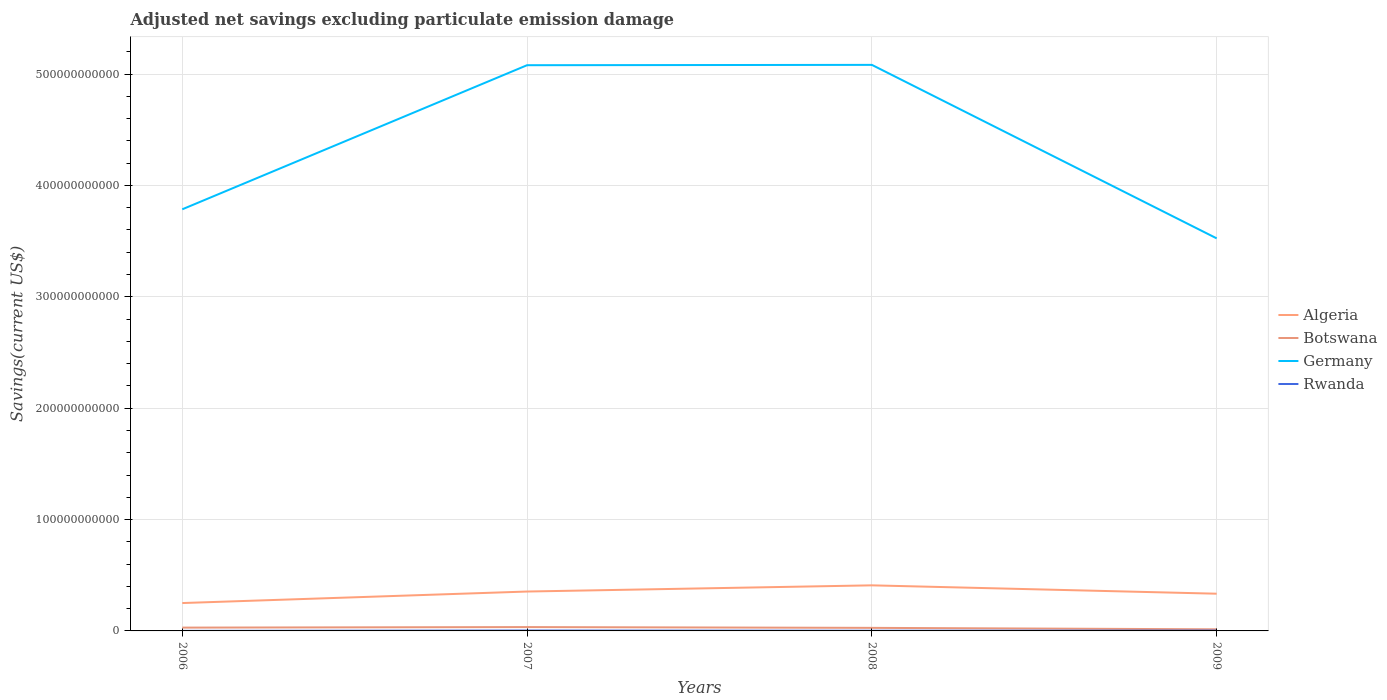How many different coloured lines are there?
Provide a short and direct response. 4. Does the line corresponding to Botswana intersect with the line corresponding to Algeria?
Provide a short and direct response. No. Is the number of lines equal to the number of legend labels?
Ensure brevity in your answer.  Yes. Across all years, what is the maximum adjusted net savings in Botswana?
Keep it short and to the point. 1.44e+09. What is the total adjusted net savings in Rwanda in the graph?
Make the answer very short. -1.05e+08. What is the difference between the highest and the second highest adjusted net savings in Germany?
Provide a short and direct response. 1.56e+11. How many lines are there?
Provide a succinct answer. 4. How many years are there in the graph?
Provide a short and direct response. 4. What is the difference between two consecutive major ticks on the Y-axis?
Offer a very short reply. 1.00e+11. Where does the legend appear in the graph?
Provide a short and direct response. Center right. How many legend labels are there?
Offer a very short reply. 4. What is the title of the graph?
Your answer should be very brief. Adjusted net savings excluding particulate emission damage. What is the label or title of the X-axis?
Your response must be concise. Years. What is the label or title of the Y-axis?
Your answer should be very brief. Savings(current US$). What is the Savings(current US$) in Algeria in 2006?
Make the answer very short. 2.50e+1. What is the Savings(current US$) of Botswana in 2006?
Your response must be concise. 2.97e+09. What is the Savings(current US$) of Germany in 2006?
Offer a terse response. 3.79e+11. What is the Savings(current US$) in Rwanda in 2006?
Give a very brief answer. 5.25e+07. What is the Savings(current US$) of Algeria in 2007?
Your response must be concise. 3.54e+1. What is the Savings(current US$) of Botswana in 2007?
Give a very brief answer. 3.46e+09. What is the Savings(current US$) in Germany in 2007?
Your response must be concise. 5.08e+11. What is the Savings(current US$) of Rwanda in 2007?
Your response must be concise. 3.66e+08. What is the Savings(current US$) of Algeria in 2008?
Your response must be concise. 4.09e+1. What is the Savings(current US$) in Botswana in 2008?
Give a very brief answer. 2.75e+09. What is the Savings(current US$) of Germany in 2008?
Keep it short and to the point. 5.08e+11. What is the Savings(current US$) in Rwanda in 2008?
Your answer should be very brief. 1.84e+08. What is the Savings(current US$) of Algeria in 2009?
Provide a succinct answer. 3.34e+1. What is the Savings(current US$) in Botswana in 2009?
Provide a succinct answer. 1.44e+09. What is the Savings(current US$) of Germany in 2009?
Offer a very short reply. 3.52e+11. What is the Savings(current US$) of Rwanda in 2009?
Offer a terse response. 2.89e+08. Across all years, what is the maximum Savings(current US$) of Algeria?
Your response must be concise. 4.09e+1. Across all years, what is the maximum Savings(current US$) of Botswana?
Make the answer very short. 3.46e+09. Across all years, what is the maximum Savings(current US$) of Germany?
Offer a terse response. 5.08e+11. Across all years, what is the maximum Savings(current US$) of Rwanda?
Offer a terse response. 3.66e+08. Across all years, what is the minimum Savings(current US$) of Algeria?
Give a very brief answer. 2.50e+1. Across all years, what is the minimum Savings(current US$) of Botswana?
Provide a short and direct response. 1.44e+09. Across all years, what is the minimum Savings(current US$) of Germany?
Your answer should be compact. 3.52e+11. Across all years, what is the minimum Savings(current US$) in Rwanda?
Offer a very short reply. 5.25e+07. What is the total Savings(current US$) in Algeria in the graph?
Ensure brevity in your answer.  1.35e+11. What is the total Savings(current US$) in Botswana in the graph?
Ensure brevity in your answer.  1.06e+1. What is the total Savings(current US$) in Germany in the graph?
Offer a very short reply. 1.75e+12. What is the total Savings(current US$) of Rwanda in the graph?
Ensure brevity in your answer.  8.91e+08. What is the difference between the Savings(current US$) in Algeria in 2006 and that in 2007?
Offer a terse response. -1.03e+1. What is the difference between the Savings(current US$) in Botswana in 2006 and that in 2007?
Your answer should be very brief. -4.86e+08. What is the difference between the Savings(current US$) in Germany in 2006 and that in 2007?
Make the answer very short. -1.29e+11. What is the difference between the Savings(current US$) of Rwanda in 2006 and that in 2007?
Offer a very short reply. -3.13e+08. What is the difference between the Savings(current US$) of Algeria in 2006 and that in 2008?
Make the answer very short. -1.59e+1. What is the difference between the Savings(current US$) in Botswana in 2006 and that in 2008?
Make the answer very short. 2.21e+08. What is the difference between the Savings(current US$) of Germany in 2006 and that in 2008?
Keep it short and to the point. -1.30e+11. What is the difference between the Savings(current US$) in Rwanda in 2006 and that in 2008?
Offer a terse response. -1.32e+08. What is the difference between the Savings(current US$) in Algeria in 2006 and that in 2009?
Your answer should be very brief. -8.39e+09. What is the difference between the Savings(current US$) of Botswana in 2006 and that in 2009?
Offer a very short reply. 1.53e+09. What is the difference between the Savings(current US$) of Germany in 2006 and that in 2009?
Give a very brief answer. 2.61e+1. What is the difference between the Savings(current US$) of Rwanda in 2006 and that in 2009?
Keep it short and to the point. -2.36e+08. What is the difference between the Savings(current US$) of Algeria in 2007 and that in 2008?
Ensure brevity in your answer.  -5.56e+09. What is the difference between the Savings(current US$) in Botswana in 2007 and that in 2008?
Give a very brief answer. 7.07e+08. What is the difference between the Savings(current US$) in Germany in 2007 and that in 2008?
Make the answer very short. -2.97e+08. What is the difference between the Savings(current US$) of Rwanda in 2007 and that in 2008?
Offer a terse response. 1.82e+08. What is the difference between the Savings(current US$) in Algeria in 2007 and that in 2009?
Keep it short and to the point. 1.95e+09. What is the difference between the Savings(current US$) of Botswana in 2007 and that in 2009?
Your answer should be very brief. 2.02e+09. What is the difference between the Savings(current US$) in Germany in 2007 and that in 2009?
Provide a succinct answer. 1.55e+11. What is the difference between the Savings(current US$) in Rwanda in 2007 and that in 2009?
Ensure brevity in your answer.  7.70e+07. What is the difference between the Savings(current US$) in Algeria in 2008 and that in 2009?
Make the answer very short. 7.50e+09. What is the difference between the Savings(current US$) in Botswana in 2008 and that in 2009?
Provide a succinct answer. 1.31e+09. What is the difference between the Savings(current US$) in Germany in 2008 and that in 2009?
Give a very brief answer. 1.56e+11. What is the difference between the Savings(current US$) in Rwanda in 2008 and that in 2009?
Make the answer very short. -1.05e+08. What is the difference between the Savings(current US$) of Algeria in 2006 and the Savings(current US$) of Botswana in 2007?
Offer a very short reply. 2.16e+1. What is the difference between the Savings(current US$) of Algeria in 2006 and the Savings(current US$) of Germany in 2007?
Offer a terse response. -4.83e+11. What is the difference between the Savings(current US$) in Algeria in 2006 and the Savings(current US$) in Rwanda in 2007?
Provide a succinct answer. 2.47e+1. What is the difference between the Savings(current US$) in Botswana in 2006 and the Savings(current US$) in Germany in 2007?
Your answer should be very brief. -5.05e+11. What is the difference between the Savings(current US$) of Botswana in 2006 and the Savings(current US$) of Rwanda in 2007?
Give a very brief answer. 2.60e+09. What is the difference between the Savings(current US$) of Germany in 2006 and the Savings(current US$) of Rwanda in 2007?
Provide a succinct answer. 3.78e+11. What is the difference between the Savings(current US$) in Algeria in 2006 and the Savings(current US$) in Botswana in 2008?
Keep it short and to the point. 2.23e+1. What is the difference between the Savings(current US$) in Algeria in 2006 and the Savings(current US$) in Germany in 2008?
Give a very brief answer. -4.83e+11. What is the difference between the Savings(current US$) of Algeria in 2006 and the Savings(current US$) of Rwanda in 2008?
Offer a terse response. 2.48e+1. What is the difference between the Savings(current US$) in Botswana in 2006 and the Savings(current US$) in Germany in 2008?
Offer a terse response. -5.05e+11. What is the difference between the Savings(current US$) of Botswana in 2006 and the Savings(current US$) of Rwanda in 2008?
Provide a succinct answer. 2.79e+09. What is the difference between the Savings(current US$) in Germany in 2006 and the Savings(current US$) in Rwanda in 2008?
Provide a succinct answer. 3.78e+11. What is the difference between the Savings(current US$) of Algeria in 2006 and the Savings(current US$) of Botswana in 2009?
Offer a very short reply. 2.36e+1. What is the difference between the Savings(current US$) in Algeria in 2006 and the Savings(current US$) in Germany in 2009?
Your answer should be very brief. -3.27e+11. What is the difference between the Savings(current US$) in Algeria in 2006 and the Savings(current US$) in Rwanda in 2009?
Your answer should be very brief. 2.47e+1. What is the difference between the Savings(current US$) in Botswana in 2006 and the Savings(current US$) in Germany in 2009?
Your answer should be very brief. -3.50e+11. What is the difference between the Savings(current US$) of Botswana in 2006 and the Savings(current US$) of Rwanda in 2009?
Offer a terse response. 2.68e+09. What is the difference between the Savings(current US$) in Germany in 2006 and the Savings(current US$) in Rwanda in 2009?
Make the answer very short. 3.78e+11. What is the difference between the Savings(current US$) of Algeria in 2007 and the Savings(current US$) of Botswana in 2008?
Your answer should be compact. 3.26e+1. What is the difference between the Savings(current US$) in Algeria in 2007 and the Savings(current US$) in Germany in 2008?
Offer a terse response. -4.73e+11. What is the difference between the Savings(current US$) in Algeria in 2007 and the Savings(current US$) in Rwanda in 2008?
Offer a terse response. 3.52e+1. What is the difference between the Savings(current US$) in Botswana in 2007 and the Savings(current US$) in Germany in 2008?
Offer a terse response. -5.05e+11. What is the difference between the Savings(current US$) in Botswana in 2007 and the Savings(current US$) in Rwanda in 2008?
Your answer should be very brief. 3.27e+09. What is the difference between the Savings(current US$) of Germany in 2007 and the Savings(current US$) of Rwanda in 2008?
Keep it short and to the point. 5.08e+11. What is the difference between the Savings(current US$) in Algeria in 2007 and the Savings(current US$) in Botswana in 2009?
Offer a very short reply. 3.39e+1. What is the difference between the Savings(current US$) of Algeria in 2007 and the Savings(current US$) of Germany in 2009?
Ensure brevity in your answer.  -3.17e+11. What is the difference between the Savings(current US$) in Algeria in 2007 and the Savings(current US$) in Rwanda in 2009?
Your response must be concise. 3.51e+1. What is the difference between the Savings(current US$) of Botswana in 2007 and the Savings(current US$) of Germany in 2009?
Offer a very short reply. -3.49e+11. What is the difference between the Savings(current US$) in Botswana in 2007 and the Savings(current US$) in Rwanda in 2009?
Give a very brief answer. 3.17e+09. What is the difference between the Savings(current US$) in Germany in 2007 and the Savings(current US$) in Rwanda in 2009?
Keep it short and to the point. 5.08e+11. What is the difference between the Savings(current US$) in Algeria in 2008 and the Savings(current US$) in Botswana in 2009?
Offer a terse response. 3.95e+1. What is the difference between the Savings(current US$) of Algeria in 2008 and the Savings(current US$) of Germany in 2009?
Your response must be concise. -3.12e+11. What is the difference between the Savings(current US$) of Algeria in 2008 and the Savings(current US$) of Rwanda in 2009?
Provide a short and direct response. 4.06e+1. What is the difference between the Savings(current US$) of Botswana in 2008 and the Savings(current US$) of Germany in 2009?
Keep it short and to the point. -3.50e+11. What is the difference between the Savings(current US$) of Botswana in 2008 and the Savings(current US$) of Rwanda in 2009?
Ensure brevity in your answer.  2.46e+09. What is the difference between the Savings(current US$) in Germany in 2008 and the Savings(current US$) in Rwanda in 2009?
Keep it short and to the point. 5.08e+11. What is the average Savings(current US$) in Algeria per year?
Make the answer very short. 3.37e+1. What is the average Savings(current US$) in Botswana per year?
Provide a succinct answer. 2.65e+09. What is the average Savings(current US$) in Germany per year?
Give a very brief answer. 4.37e+11. What is the average Savings(current US$) in Rwanda per year?
Provide a short and direct response. 2.23e+08. In the year 2006, what is the difference between the Savings(current US$) in Algeria and Savings(current US$) in Botswana?
Offer a terse response. 2.21e+1. In the year 2006, what is the difference between the Savings(current US$) in Algeria and Savings(current US$) in Germany?
Your answer should be compact. -3.54e+11. In the year 2006, what is the difference between the Savings(current US$) of Algeria and Savings(current US$) of Rwanda?
Provide a short and direct response. 2.50e+1. In the year 2006, what is the difference between the Savings(current US$) of Botswana and Savings(current US$) of Germany?
Offer a very short reply. -3.76e+11. In the year 2006, what is the difference between the Savings(current US$) of Botswana and Savings(current US$) of Rwanda?
Your answer should be very brief. 2.92e+09. In the year 2006, what is the difference between the Savings(current US$) in Germany and Savings(current US$) in Rwanda?
Provide a short and direct response. 3.79e+11. In the year 2007, what is the difference between the Savings(current US$) in Algeria and Savings(current US$) in Botswana?
Give a very brief answer. 3.19e+1. In the year 2007, what is the difference between the Savings(current US$) of Algeria and Savings(current US$) of Germany?
Provide a succinct answer. -4.73e+11. In the year 2007, what is the difference between the Savings(current US$) in Algeria and Savings(current US$) in Rwanda?
Ensure brevity in your answer.  3.50e+1. In the year 2007, what is the difference between the Savings(current US$) in Botswana and Savings(current US$) in Germany?
Provide a succinct answer. -5.05e+11. In the year 2007, what is the difference between the Savings(current US$) of Botswana and Savings(current US$) of Rwanda?
Your answer should be very brief. 3.09e+09. In the year 2007, what is the difference between the Savings(current US$) of Germany and Savings(current US$) of Rwanda?
Your answer should be compact. 5.08e+11. In the year 2008, what is the difference between the Savings(current US$) of Algeria and Savings(current US$) of Botswana?
Provide a short and direct response. 3.82e+1. In the year 2008, what is the difference between the Savings(current US$) in Algeria and Savings(current US$) in Germany?
Provide a short and direct response. -4.67e+11. In the year 2008, what is the difference between the Savings(current US$) in Algeria and Savings(current US$) in Rwanda?
Keep it short and to the point. 4.07e+1. In the year 2008, what is the difference between the Savings(current US$) in Botswana and Savings(current US$) in Germany?
Your answer should be compact. -5.06e+11. In the year 2008, what is the difference between the Savings(current US$) in Botswana and Savings(current US$) in Rwanda?
Keep it short and to the point. 2.56e+09. In the year 2008, what is the difference between the Savings(current US$) in Germany and Savings(current US$) in Rwanda?
Offer a terse response. 5.08e+11. In the year 2009, what is the difference between the Savings(current US$) in Algeria and Savings(current US$) in Botswana?
Ensure brevity in your answer.  3.20e+1. In the year 2009, what is the difference between the Savings(current US$) of Algeria and Savings(current US$) of Germany?
Offer a terse response. -3.19e+11. In the year 2009, what is the difference between the Savings(current US$) in Algeria and Savings(current US$) in Rwanda?
Ensure brevity in your answer.  3.31e+1. In the year 2009, what is the difference between the Savings(current US$) of Botswana and Savings(current US$) of Germany?
Give a very brief answer. -3.51e+11. In the year 2009, what is the difference between the Savings(current US$) in Botswana and Savings(current US$) in Rwanda?
Keep it short and to the point. 1.15e+09. In the year 2009, what is the difference between the Savings(current US$) in Germany and Savings(current US$) in Rwanda?
Provide a short and direct response. 3.52e+11. What is the ratio of the Savings(current US$) in Algeria in 2006 to that in 2007?
Keep it short and to the point. 0.71. What is the ratio of the Savings(current US$) in Botswana in 2006 to that in 2007?
Give a very brief answer. 0.86. What is the ratio of the Savings(current US$) in Germany in 2006 to that in 2007?
Make the answer very short. 0.75. What is the ratio of the Savings(current US$) in Rwanda in 2006 to that in 2007?
Provide a short and direct response. 0.14. What is the ratio of the Savings(current US$) in Algeria in 2006 to that in 2008?
Give a very brief answer. 0.61. What is the ratio of the Savings(current US$) of Botswana in 2006 to that in 2008?
Give a very brief answer. 1.08. What is the ratio of the Savings(current US$) of Germany in 2006 to that in 2008?
Keep it short and to the point. 0.74. What is the ratio of the Savings(current US$) of Rwanda in 2006 to that in 2008?
Offer a very short reply. 0.29. What is the ratio of the Savings(current US$) in Algeria in 2006 to that in 2009?
Offer a very short reply. 0.75. What is the ratio of the Savings(current US$) in Botswana in 2006 to that in 2009?
Keep it short and to the point. 2.06. What is the ratio of the Savings(current US$) in Germany in 2006 to that in 2009?
Your response must be concise. 1.07. What is the ratio of the Savings(current US$) of Rwanda in 2006 to that in 2009?
Your response must be concise. 0.18. What is the ratio of the Savings(current US$) of Algeria in 2007 to that in 2008?
Your answer should be very brief. 0.86. What is the ratio of the Savings(current US$) of Botswana in 2007 to that in 2008?
Keep it short and to the point. 1.26. What is the ratio of the Savings(current US$) in Germany in 2007 to that in 2008?
Your response must be concise. 1. What is the ratio of the Savings(current US$) of Rwanda in 2007 to that in 2008?
Your answer should be compact. 1.99. What is the ratio of the Savings(current US$) of Algeria in 2007 to that in 2009?
Offer a terse response. 1.06. What is the ratio of the Savings(current US$) in Botswana in 2007 to that in 2009?
Offer a terse response. 2.4. What is the ratio of the Savings(current US$) of Germany in 2007 to that in 2009?
Provide a succinct answer. 1.44. What is the ratio of the Savings(current US$) in Rwanda in 2007 to that in 2009?
Keep it short and to the point. 1.27. What is the ratio of the Savings(current US$) of Algeria in 2008 to that in 2009?
Offer a terse response. 1.22. What is the ratio of the Savings(current US$) in Botswana in 2008 to that in 2009?
Your answer should be very brief. 1.91. What is the ratio of the Savings(current US$) in Germany in 2008 to that in 2009?
Offer a terse response. 1.44. What is the ratio of the Savings(current US$) in Rwanda in 2008 to that in 2009?
Offer a terse response. 0.64. What is the difference between the highest and the second highest Savings(current US$) of Algeria?
Your answer should be compact. 5.56e+09. What is the difference between the highest and the second highest Savings(current US$) in Botswana?
Your answer should be very brief. 4.86e+08. What is the difference between the highest and the second highest Savings(current US$) of Germany?
Your answer should be compact. 2.97e+08. What is the difference between the highest and the second highest Savings(current US$) in Rwanda?
Provide a short and direct response. 7.70e+07. What is the difference between the highest and the lowest Savings(current US$) in Algeria?
Provide a succinct answer. 1.59e+1. What is the difference between the highest and the lowest Savings(current US$) of Botswana?
Provide a succinct answer. 2.02e+09. What is the difference between the highest and the lowest Savings(current US$) of Germany?
Make the answer very short. 1.56e+11. What is the difference between the highest and the lowest Savings(current US$) of Rwanda?
Make the answer very short. 3.13e+08. 